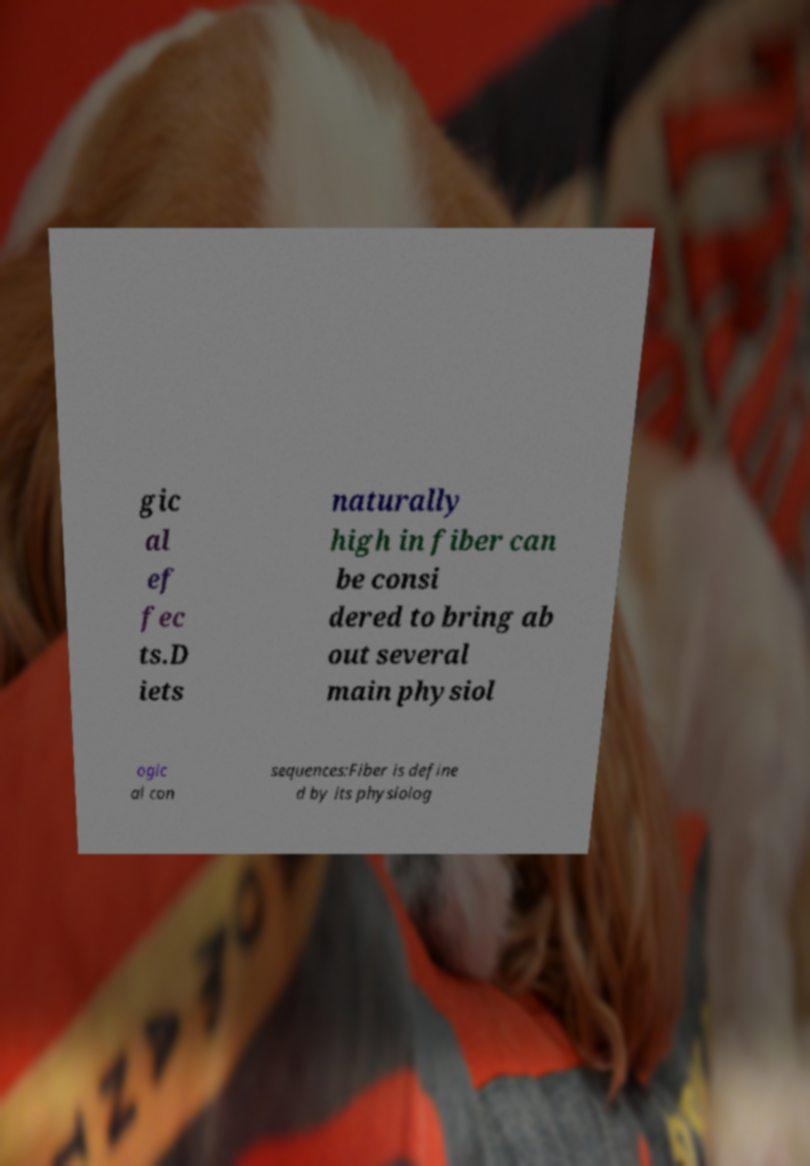Could you assist in decoding the text presented in this image and type it out clearly? gic al ef fec ts.D iets naturally high in fiber can be consi dered to bring ab out several main physiol ogic al con sequences:Fiber is define d by its physiolog 